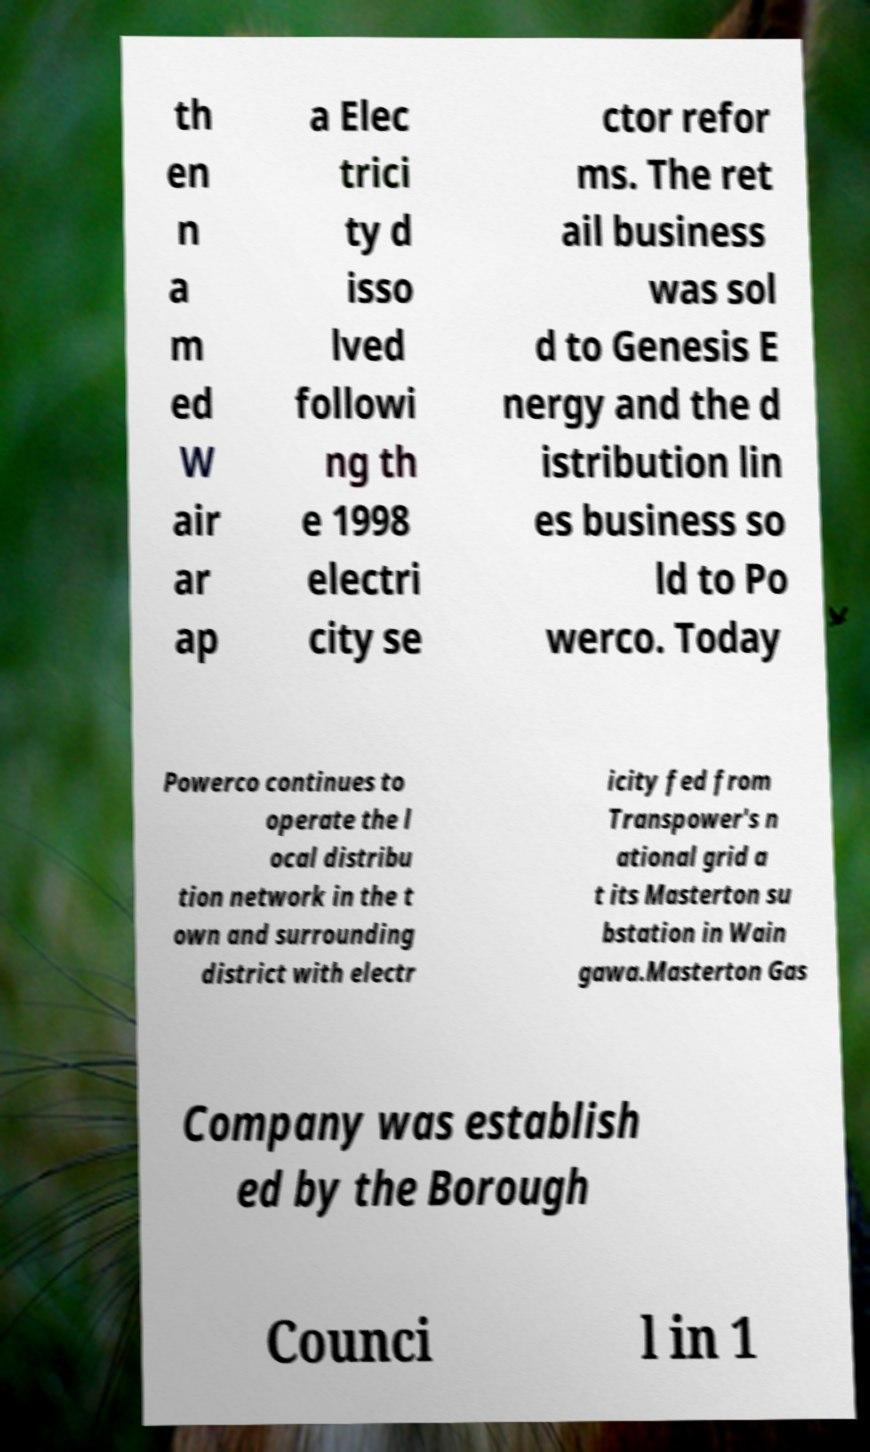Please identify and transcribe the text found in this image. th en n a m ed W air ar ap a Elec trici ty d isso lved followi ng th e 1998 electri city se ctor refor ms. The ret ail business was sol d to Genesis E nergy and the d istribution lin es business so ld to Po werco. Today Powerco continues to operate the l ocal distribu tion network in the t own and surrounding district with electr icity fed from Transpower's n ational grid a t its Masterton su bstation in Wain gawa.Masterton Gas Company was establish ed by the Borough Counci l in 1 